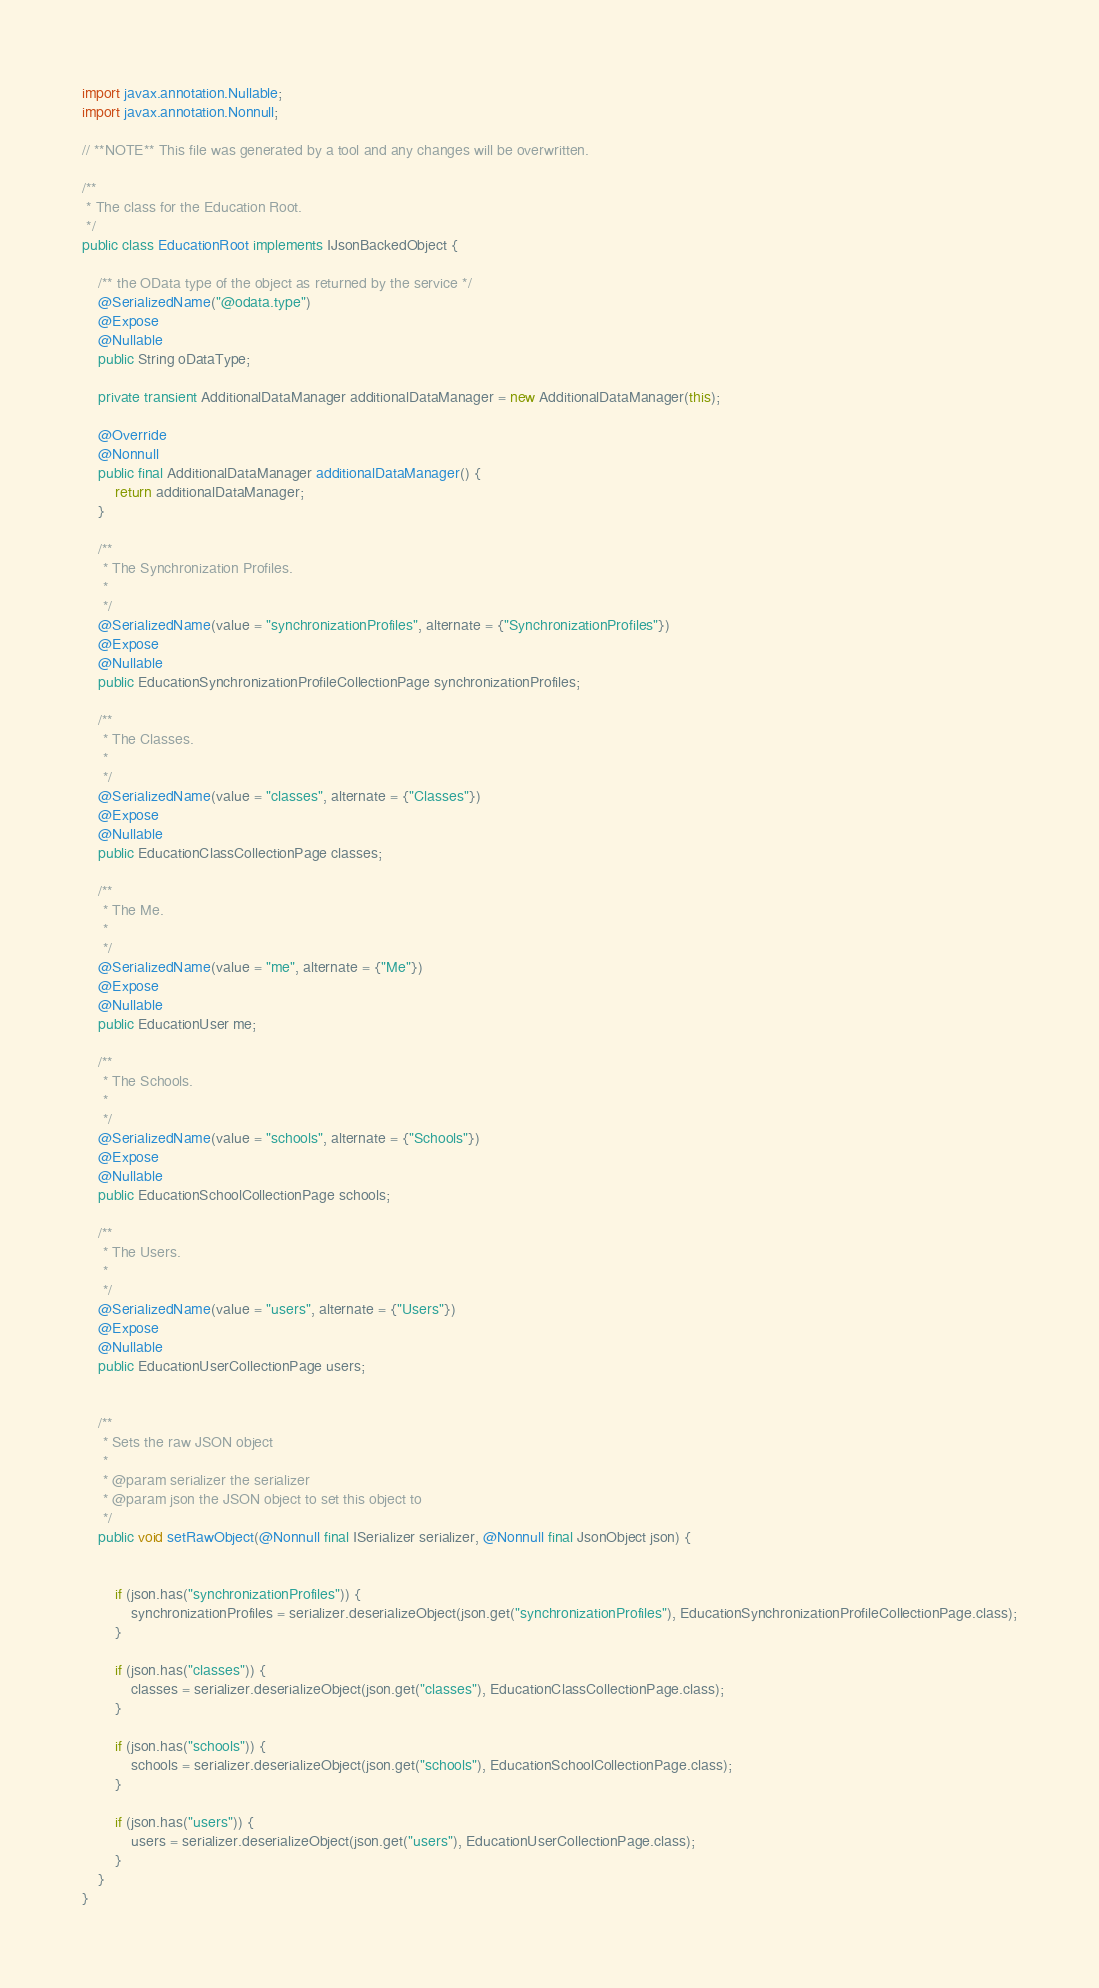<code> <loc_0><loc_0><loc_500><loc_500><_Java_>import javax.annotation.Nullable;
import javax.annotation.Nonnull;

// **NOTE** This file was generated by a tool and any changes will be overwritten.

/**
 * The class for the Education Root.
 */
public class EducationRoot implements IJsonBackedObject {

    /** the OData type of the object as returned by the service */
    @SerializedName("@odata.type")
    @Expose
    @Nullable
    public String oDataType;

    private transient AdditionalDataManager additionalDataManager = new AdditionalDataManager(this);

    @Override
    @Nonnull
    public final AdditionalDataManager additionalDataManager() {
        return additionalDataManager;
    }

    /**
     * The Synchronization Profiles.
     * 
     */
    @SerializedName(value = "synchronizationProfiles", alternate = {"SynchronizationProfiles"})
    @Expose
	@Nullable
    public EducationSynchronizationProfileCollectionPage synchronizationProfiles;

    /**
     * The Classes.
     * 
     */
    @SerializedName(value = "classes", alternate = {"Classes"})
    @Expose
	@Nullable
    public EducationClassCollectionPage classes;

    /**
     * The Me.
     * 
     */
    @SerializedName(value = "me", alternate = {"Me"})
    @Expose
	@Nullable
    public EducationUser me;

    /**
     * The Schools.
     * 
     */
    @SerializedName(value = "schools", alternate = {"Schools"})
    @Expose
	@Nullable
    public EducationSchoolCollectionPage schools;

    /**
     * The Users.
     * 
     */
    @SerializedName(value = "users", alternate = {"Users"})
    @Expose
	@Nullable
    public EducationUserCollectionPage users;


    /**
     * Sets the raw JSON object
     *
     * @param serializer the serializer
     * @param json the JSON object to set this object to
     */
    public void setRawObject(@Nonnull final ISerializer serializer, @Nonnull final JsonObject json) {


        if (json.has("synchronizationProfiles")) {
            synchronizationProfiles = serializer.deserializeObject(json.get("synchronizationProfiles"), EducationSynchronizationProfileCollectionPage.class);
        }

        if (json.has("classes")) {
            classes = serializer.deserializeObject(json.get("classes"), EducationClassCollectionPage.class);
        }

        if (json.has("schools")) {
            schools = serializer.deserializeObject(json.get("schools"), EducationSchoolCollectionPage.class);
        }

        if (json.has("users")) {
            users = serializer.deserializeObject(json.get("users"), EducationUserCollectionPage.class);
        }
    }
}
</code> 